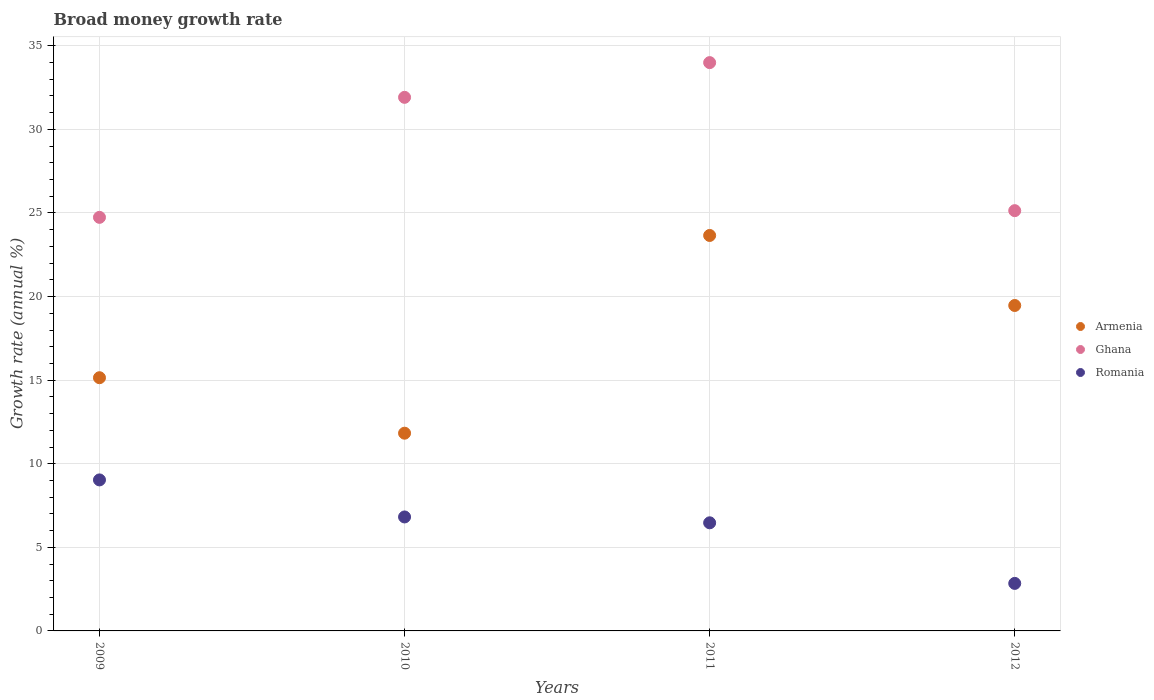How many different coloured dotlines are there?
Ensure brevity in your answer.  3. Is the number of dotlines equal to the number of legend labels?
Ensure brevity in your answer.  Yes. What is the growth rate in Armenia in 2011?
Your answer should be very brief. 23.66. Across all years, what is the maximum growth rate in Armenia?
Your response must be concise. 23.66. Across all years, what is the minimum growth rate in Romania?
Make the answer very short. 2.84. In which year was the growth rate in Ghana maximum?
Your answer should be very brief. 2011. What is the total growth rate in Romania in the graph?
Provide a succinct answer. 25.16. What is the difference between the growth rate in Armenia in 2009 and that in 2010?
Your answer should be very brief. 3.32. What is the difference between the growth rate in Romania in 2009 and the growth rate in Armenia in 2012?
Give a very brief answer. -10.43. What is the average growth rate in Romania per year?
Provide a short and direct response. 6.29. In the year 2012, what is the difference between the growth rate in Romania and growth rate in Armenia?
Provide a succinct answer. -16.62. What is the ratio of the growth rate in Ghana in 2010 to that in 2011?
Provide a succinct answer. 0.94. Is the growth rate in Ghana in 2009 less than that in 2011?
Make the answer very short. Yes. What is the difference between the highest and the second highest growth rate in Romania?
Your answer should be compact. 2.22. What is the difference between the highest and the lowest growth rate in Armenia?
Your answer should be very brief. 11.83. Is it the case that in every year, the sum of the growth rate in Romania and growth rate in Armenia  is greater than the growth rate in Ghana?
Ensure brevity in your answer.  No. Does the growth rate in Romania monotonically increase over the years?
Provide a short and direct response. No. Is the growth rate in Ghana strictly less than the growth rate in Romania over the years?
Give a very brief answer. No. How many dotlines are there?
Keep it short and to the point. 3. What is the difference between two consecutive major ticks on the Y-axis?
Offer a terse response. 5. Are the values on the major ticks of Y-axis written in scientific E-notation?
Your answer should be very brief. No. Does the graph contain any zero values?
Give a very brief answer. No. Does the graph contain grids?
Make the answer very short. Yes. Where does the legend appear in the graph?
Keep it short and to the point. Center right. What is the title of the graph?
Your answer should be very brief. Broad money growth rate. What is the label or title of the Y-axis?
Your response must be concise. Growth rate (annual %). What is the Growth rate (annual %) of Armenia in 2009?
Make the answer very short. 15.15. What is the Growth rate (annual %) of Ghana in 2009?
Your answer should be compact. 24.74. What is the Growth rate (annual %) in Romania in 2009?
Give a very brief answer. 9.03. What is the Growth rate (annual %) of Armenia in 2010?
Provide a succinct answer. 11.83. What is the Growth rate (annual %) of Ghana in 2010?
Provide a succinct answer. 31.92. What is the Growth rate (annual %) in Romania in 2010?
Keep it short and to the point. 6.82. What is the Growth rate (annual %) in Armenia in 2011?
Give a very brief answer. 23.66. What is the Growth rate (annual %) of Ghana in 2011?
Offer a very short reply. 33.99. What is the Growth rate (annual %) of Romania in 2011?
Provide a succinct answer. 6.47. What is the Growth rate (annual %) of Armenia in 2012?
Your answer should be compact. 19.47. What is the Growth rate (annual %) of Ghana in 2012?
Make the answer very short. 25.14. What is the Growth rate (annual %) of Romania in 2012?
Ensure brevity in your answer.  2.84. Across all years, what is the maximum Growth rate (annual %) of Armenia?
Your response must be concise. 23.66. Across all years, what is the maximum Growth rate (annual %) in Ghana?
Ensure brevity in your answer.  33.99. Across all years, what is the maximum Growth rate (annual %) in Romania?
Your answer should be very brief. 9.03. Across all years, what is the minimum Growth rate (annual %) of Armenia?
Keep it short and to the point. 11.83. Across all years, what is the minimum Growth rate (annual %) of Ghana?
Offer a very short reply. 24.74. Across all years, what is the minimum Growth rate (annual %) of Romania?
Ensure brevity in your answer.  2.84. What is the total Growth rate (annual %) of Armenia in the graph?
Provide a succinct answer. 70.1. What is the total Growth rate (annual %) of Ghana in the graph?
Provide a short and direct response. 115.79. What is the total Growth rate (annual %) of Romania in the graph?
Ensure brevity in your answer.  25.16. What is the difference between the Growth rate (annual %) in Armenia in 2009 and that in 2010?
Your answer should be compact. 3.32. What is the difference between the Growth rate (annual %) of Ghana in 2009 and that in 2010?
Your answer should be very brief. -7.18. What is the difference between the Growth rate (annual %) of Romania in 2009 and that in 2010?
Offer a very short reply. 2.22. What is the difference between the Growth rate (annual %) in Armenia in 2009 and that in 2011?
Provide a succinct answer. -8.51. What is the difference between the Growth rate (annual %) in Ghana in 2009 and that in 2011?
Make the answer very short. -9.26. What is the difference between the Growth rate (annual %) of Romania in 2009 and that in 2011?
Provide a succinct answer. 2.57. What is the difference between the Growth rate (annual %) in Armenia in 2009 and that in 2012?
Offer a very short reply. -4.32. What is the difference between the Growth rate (annual %) of Ghana in 2009 and that in 2012?
Offer a terse response. -0.4. What is the difference between the Growth rate (annual %) in Romania in 2009 and that in 2012?
Keep it short and to the point. 6.19. What is the difference between the Growth rate (annual %) in Armenia in 2010 and that in 2011?
Give a very brief answer. -11.83. What is the difference between the Growth rate (annual %) in Ghana in 2010 and that in 2011?
Ensure brevity in your answer.  -2.08. What is the difference between the Growth rate (annual %) in Romania in 2010 and that in 2011?
Your answer should be very brief. 0.35. What is the difference between the Growth rate (annual %) of Armenia in 2010 and that in 2012?
Provide a short and direct response. -7.64. What is the difference between the Growth rate (annual %) in Ghana in 2010 and that in 2012?
Provide a short and direct response. 6.78. What is the difference between the Growth rate (annual %) in Romania in 2010 and that in 2012?
Offer a terse response. 3.97. What is the difference between the Growth rate (annual %) of Armenia in 2011 and that in 2012?
Offer a terse response. 4.19. What is the difference between the Growth rate (annual %) in Ghana in 2011 and that in 2012?
Give a very brief answer. 8.86. What is the difference between the Growth rate (annual %) of Romania in 2011 and that in 2012?
Give a very brief answer. 3.62. What is the difference between the Growth rate (annual %) of Armenia in 2009 and the Growth rate (annual %) of Ghana in 2010?
Offer a terse response. -16.77. What is the difference between the Growth rate (annual %) in Armenia in 2009 and the Growth rate (annual %) in Romania in 2010?
Provide a succinct answer. 8.33. What is the difference between the Growth rate (annual %) of Ghana in 2009 and the Growth rate (annual %) of Romania in 2010?
Ensure brevity in your answer.  17.92. What is the difference between the Growth rate (annual %) in Armenia in 2009 and the Growth rate (annual %) in Ghana in 2011?
Your response must be concise. -18.85. What is the difference between the Growth rate (annual %) in Armenia in 2009 and the Growth rate (annual %) in Romania in 2011?
Give a very brief answer. 8.68. What is the difference between the Growth rate (annual %) in Ghana in 2009 and the Growth rate (annual %) in Romania in 2011?
Offer a very short reply. 18.27. What is the difference between the Growth rate (annual %) in Armenia in 2009 and the Growth rate (annual %) in Ghana in 2012?
Offer a very short reply. -9.99. What is the difference between the Growth rate (annual %) in Armenia in 2009 and the Growth rate (annual %) in Romania in 2012?
Give a very brief answer. 12.3. What is the difference between the Growth rate (annual %) in Ghana in 2009 and the Growth rate (annual %) in Romania in 2012?
Your answer should be compact. 21.9. What is the difference between the Growth rate (annual %) in Armenia in 2010 and the Growth rate (annual %) in Ghana in 2011?
Give a very brief answer. -22.17. What is the difference between the Growth rate (annual %) of Armenia in 2010 and the Growth rate (annual %) of Romania in 2011?
Make the answer very short. 5.36. What is the difference between the Growth rate (annual %) of Ghana in 2010 and the Growth rate (annual %) of Romania in 2011?
Make the answer very short. 25.45. What is the difference between the Growth rate (annual %) in Armenia in 2010 and the Growth rate (annual %) in Ghana in 2012?
Make the answer very short. -13.31. What is the difference between the Growth rate (annual %) of Armenia in 2010 and the Growth rate (annual %) of Romania in 2012?
Provide a short and direct response. 8.99. What is the difference between the Growth rate (annual %) of Ghana in 2010 and the Growth rate (annual %) of Romania in 2012?
Ensure brevity in your answer.  29.08. What is the difference between the Growth rate (annual %) in Armenia in 2011 and the Growth rate (annual %) in Ghana in 2012?
Provide a succinct answer. -1.48. What is the difference between the Growth rate (annual %) of Armenia in 2011 and the Growth rate (annual %) of Romania in 2012?
Offer a very short reply. 20.81. What is the difference between the Growth rate (annual %) in Ghana in 2011 and the Growth rate (annual %) in Romania in 2012?
Give a very brief answer. 31.15. What is the average Growth rate (annual %) of Armenia per year?
Make the answer very short. 17.52. What is the average Growth rate (annual %) of Ghana per year?
Offer a very short reply. 28.95. What is the average Growth rate (annual %) of Romania per year?
Ensure brevity in your answer.  6.29. In the year 2009, what is the difference between the Growth rate (annual %) of Armenia and Growth rate (annual %) of Ghana?
Your response must be concise. -9.59. In the year 2009, what is the difference between the Growth rate (annual %) in Armenia and Growth rate (annual %) in Romania?
Your response must be concise. 6.11. In the year 2009, what is the difference between the Growth rate (annual %) of Ghana and Growth rate (annual %) of Romania?
Provide a short and direct response. 15.71. In the year 2010, what is the difference between the Growth rate (annual %) in Armenia and Growth rate (annual %) in Ghana?
Make the answer very short. -20.09. In the year 2010, what is the difference between the Growth rate (annual %) in Armenia and Growth rate (annual %) in Romania?
Make the answer very short. 5.01. In the year 2010, what is the difference between the Growth rate (annual %) in Ghana and Growth rate (annual %) in Romania?
Offer a terse response. 25.1. In the year 2011, what is the difference between the Growth rate (annual %) in Armenia and Growth rate (annual %) in Ghana?
Provide a succinct answer. -10.34. In the year 2011, what is the difference between the Growth rate (annual %) of Armenia and Growth rate (annual %) of Romania?
Provide a succinct answer. 17.19. In the year 2011, what is the difference between the Growth rate (annual %) of Ghana and Growth rate (annual %) of Romania?
Offer a terse response. 27.53. In the year 2012, what is the difference between the Growth rate (annual %) of Armenia and Growth rate (annual %) of Ghana?
Keep it short and to the point. -5.67. In the year 2012, what is the difference between the Growth rate (annual %) in Armenia and Growth rate (annual %) in Romania?
Keep it short and to the point. 16.62. In the year 2012, what is the difference between the Growth rate (annual %) in Ghana and Growth rate (annual %) in Romania?
Provide a succinct answer. 22.3. What is the ratio of the Growth rate (annual %) in Armenia in 2009 to that in 2010?
Make the answer very short. 1.28. What is the ratio of the Growth rate (annual %) in Ghana in 2009 to that in 2010?
Your response must be concise. 0.78. What is the ratio of the Growth rate (annual %) in Romania in 2009 to that in 2010?
Ensure brevity in your answer.  1.32. What is the ratio of the Growth rate (annual %) in Armenia in 2009 to that in 2011?
Offer a terse response. 0.64. What is the ratio of the Growth rate (annual %) in Ghana in 2009 to that in 2011?
Offer a very short reply. 0.73. What is the ratio of the Growth rate (annual %) in Romania in 2009 to that in 2011?
Give a very brief answer. 1.4. What is the ratio of the Growth rate (annual %) in Armenia in 2009 to that in 2012?
Keep it short and to the point. 0.78. What is the ratio of the Growth rate (annual %) of Ghana in 2009 to that in 2012?
Keep it short and to the point. 0.98. What is the ratio of the Growth rate (annual %) of Romania in 2009 to that in 2012?
Offer a terse response. 3.18. What is the ratio of the Growth rate (annual %) in Ghana in 2010 to that in 2011?
Your response must be concise. 0.94. What is the ratio of the Growth rate (annual %) in Romania in 2010 to that in 2011?
Your response must be concise. 1.05. What is the ratio of the Growth rate (annual %) of Armenia in 2010 to that in 2012?
Keep it short and to the point. 0.61. What is the ratio of the Growth rate (annual %) in Ghana in 2010 to that in 2012?
Your answer should be compact. 1.27. What is the ratio of the Growth rate (annual %) in Romania in 2010 to that in 2012?
Ensure brevity in your answer.  2.4. What is the ratio of the Growth rate (annual %) in Armenia in 2011 to that in 2012?
Your response must be concise. 1.22. What is the ratio of the Growth rate (annual %) of Ghana in 2011 to that in 2012?
Ensure brevity in your answer.  1.35. What is the ratio of the Growth rate (annual %) of Romania in 2011 to that in 2012?
Your answer should be compact. 2.28. What is the difference between the highest and the second highest Growth rate (annual %) in Armenia?
Make the answer very short. 4.19. What is the difference between the highest and the second highest Growth rate (annual %) of Ghana?
Provide a short and direct response. 2.08. What is the difference between the highest and the second highest Growth rate (annual %) in Romania?
Provide a short and direct response. 2.22. What is the difference between the highest and the lowest Growth rate (annual %) in Armenia?
Make the answer very short. 11.83. What is the difference between the highest and the lowest Growth rate (annual %) in Ghana?
Provide a short and direct response. 9.26. What is the difference between the highest and the lowest Growth rate (annual %) of Romania?
Keep it short and to the point. 6.19. 